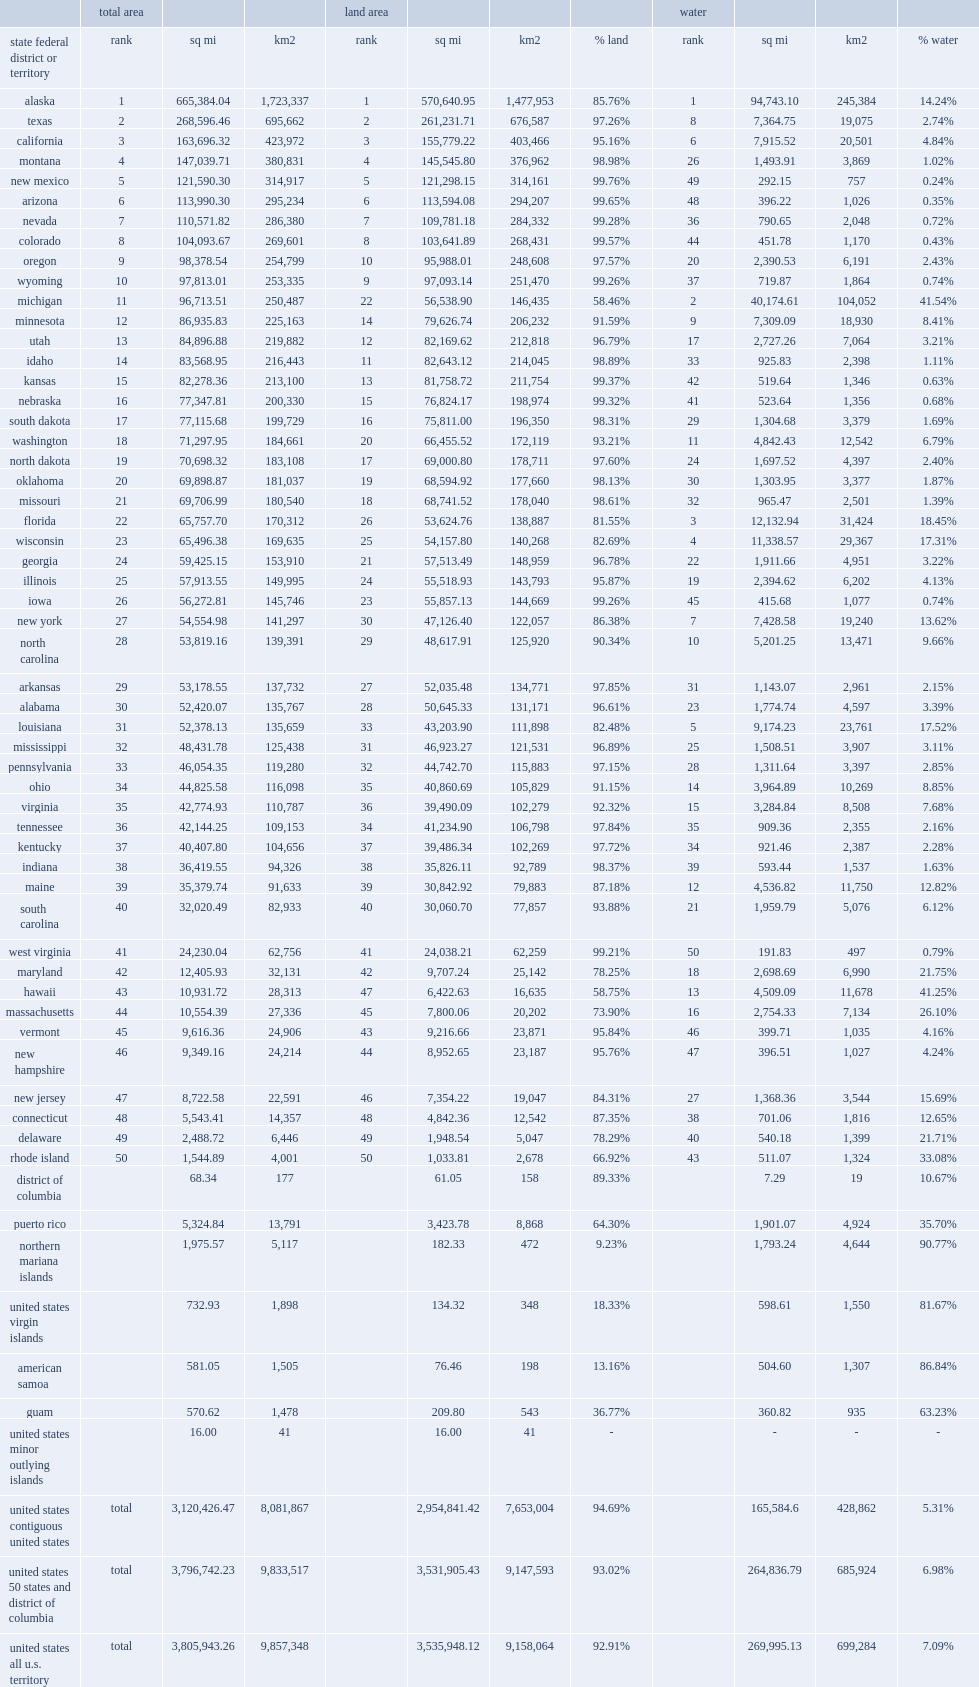What is the south dakota's rank of largest state by area of the 50 united states? 17.0. 